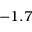Convert formula to latex. <formula><loc_0><loc_0><loc_500><loc_500>- 1 . 7</formula> 